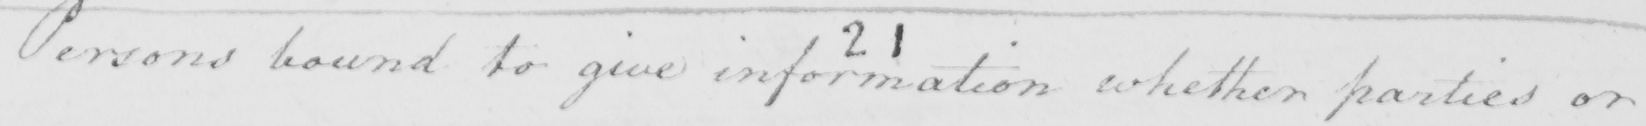Please transcribe the handwritten text in this image. Persons bound to give information whether parties or 